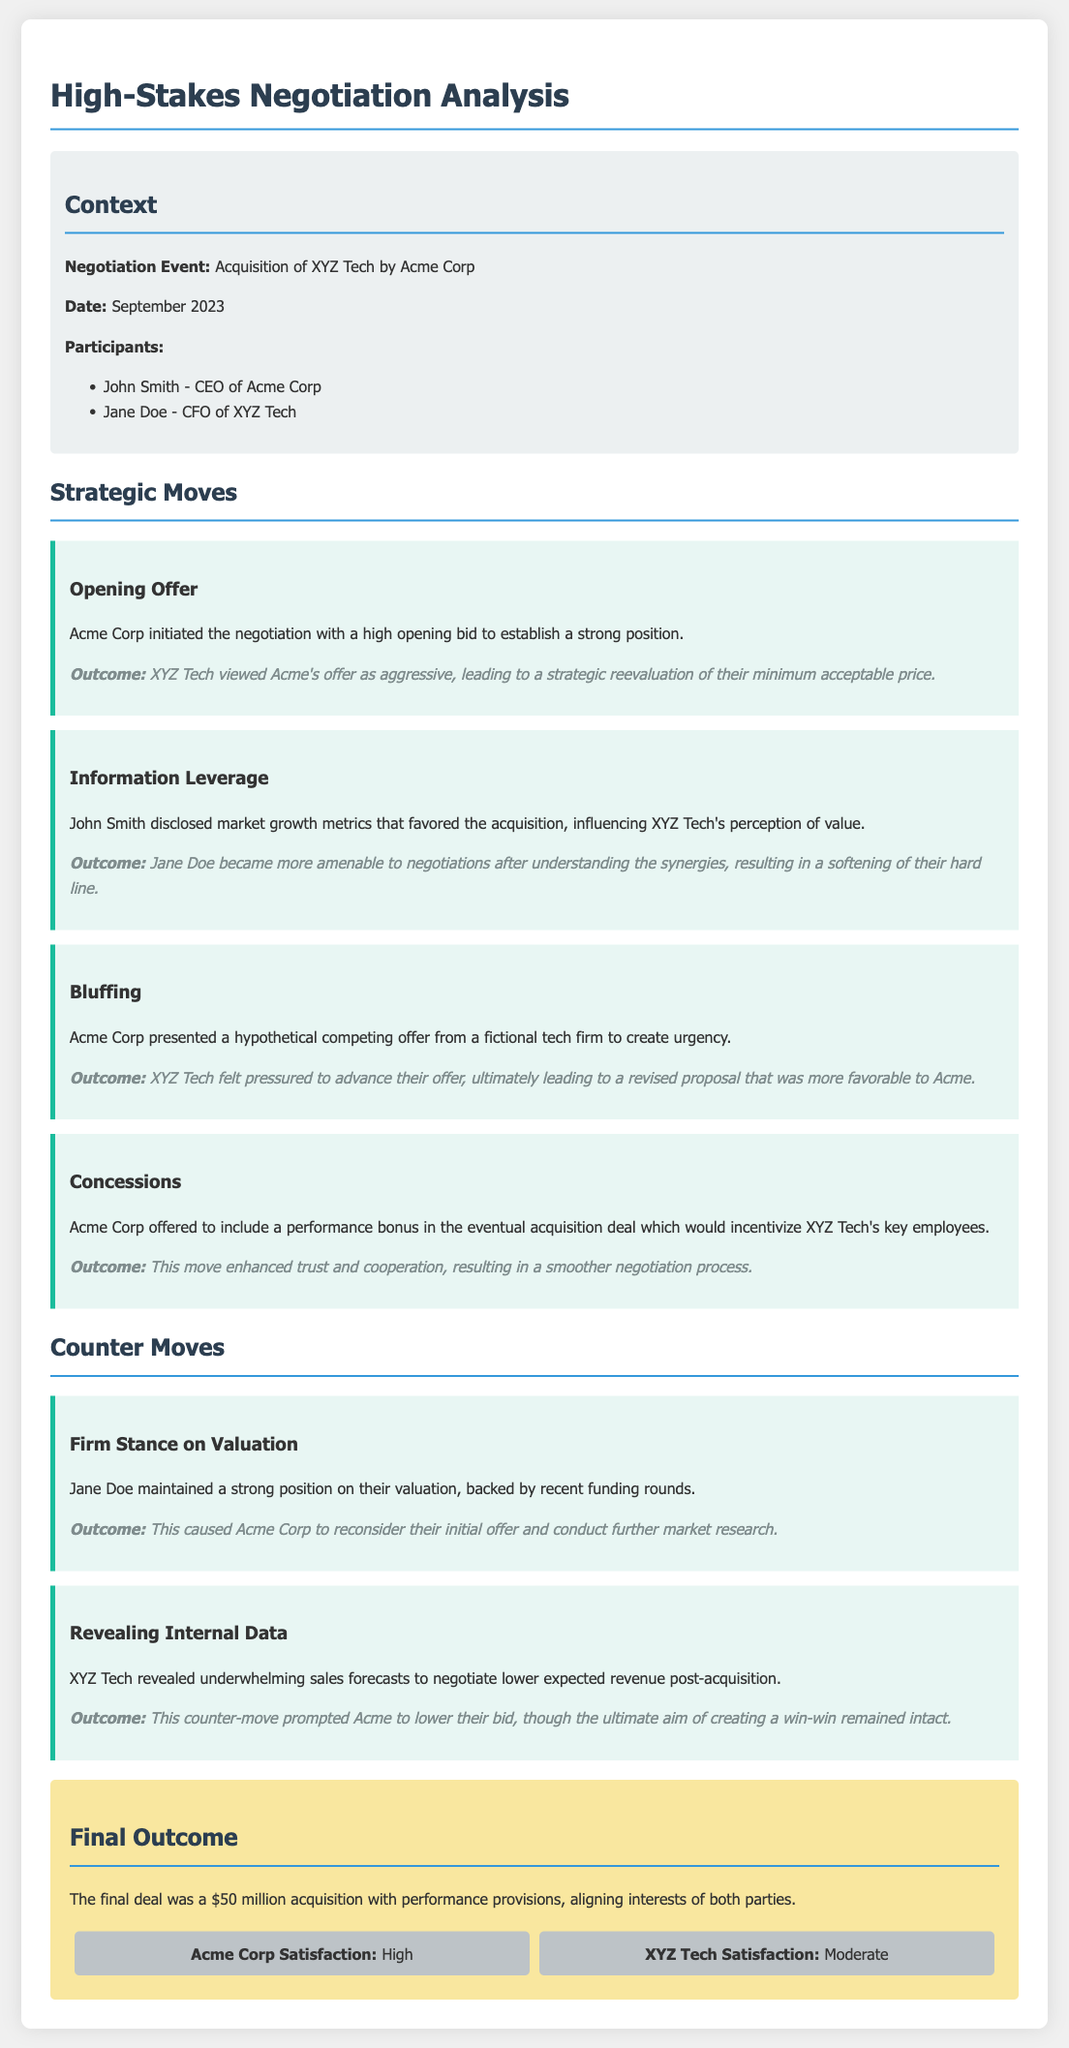What was the negotiation event? The negotiation event mentioned in the document is the acquisition of XYZ Tech by Acme Corp.
Answer: Acquisition of XYZ Tech by Acme Corp Who was the CEO of Acme Corp? The document specifies that John Smith was the CEO of Acme Corp.
Answer: John Smith What was Acme Corp's opening strategy? According to the document, Acme Corp initiated the negotiation with a high opening bid.
Answer: High opening bid What counter-move did Jane Doe use regarding valuation? The document states that Jane Doe maintained a strong position on their valuation, backed by recent funding rounds.
Answer: Firm stance on valuation What was the final deal amount? The final deal amount listed in the document is $50 million.
Answer: $50 million How did Acme Corp create pressure during negotiations? The document describes that Acme Corp presented a hypothetical competing offer to create urgency.
Answer: Hypothetical competing offer What was the satisfaction level of Acme Corp? The satisfaction level of Acme Corp reported in the document is high.
Answer: High What provision was included to enhance trust? According to the document, Acme Corp offered to include a performance bonus.
Answer: Performance bonus What was XYZ Tech's satisfaction level? The document indicates that XYZ Tech's satisfaction level was moderate.
Answer: Moderate 